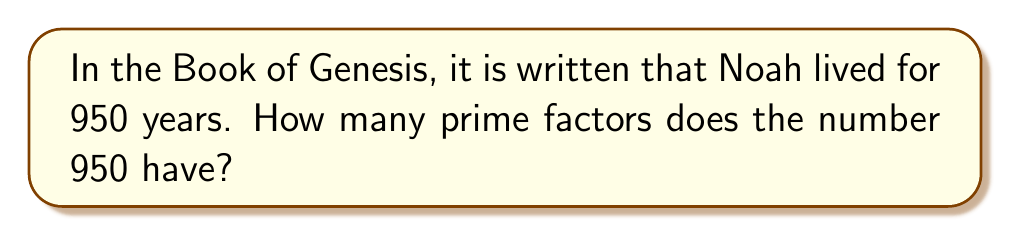Provide a solution to this math problem. Let us approach this question with patience and reflection, as befits our calling.

1. First, we must understand what prime factors are. Prime factors are prime numbers that, when multiplied together, produce the given number.

2. To find the prime factors of 950, we shall divide it by the smallest prime number that divides evenly into it, and continue this process until we can divide no more.

3. Let us begin:
   $950 = 2 \times 475$
   $475 = 5 \times 95$
   $95 = 5 \times 19$

4. We have now broken 950 down into its prime factors:
   $950 = 2 \times 5 \times 5 \times 19$

5. We can write this more succinctly as:
   $950 = 2 \times 5^2 \times 19$

6. Now, we must count the distinct prime factors. Even though 5 appears twice, we count it only once.

7. Therefore, the distinct prime factors are 2, 5, and 19.

8. Counting these, we find that there are 3 distinct prime factors.
Answer: 3 